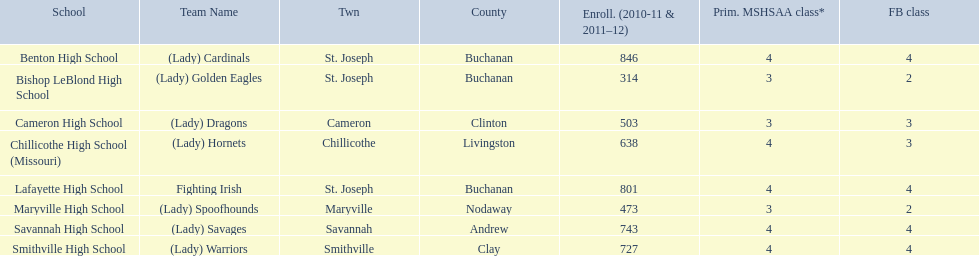What were the schools enrolled in 2010-2011 Benton High School, Bishop LeBlond High School, Cameron High School, Chillicothe High School (Missouri), Lafayette High School, Maryville High School, Savannah High School, Smithville High School. How many were enrolled in each? 846, 314, 503, 638, 801, 473, 743, 727. Which is the lowest number? 314. Which school had this number of students? Bishop LeBlond High School. 